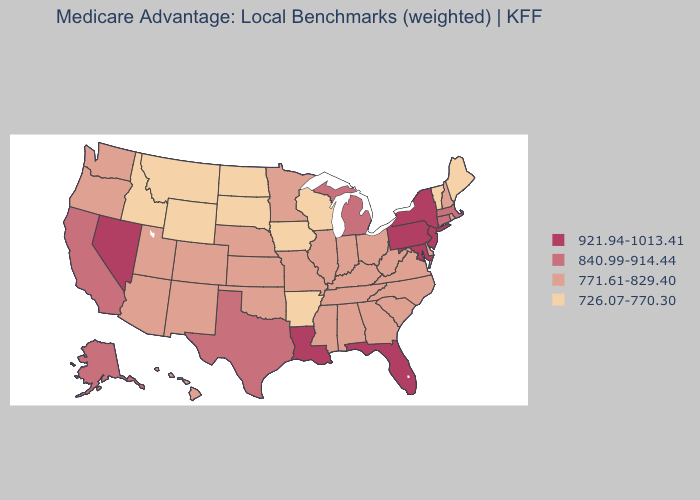Does the map have missing data?
Answer briefly. No. Does Minnesota have the same value as Alaska?
Short answer required. No. Which states hav the highest value in the South?
Write a very short answer. Florida, Louisiana, Maryland. Does Wisconsin have the lowest value in the MidWest?
Keep it brief. Yes. Which states have the lowest value in the USA?
Write a very short answer. Arkansas, Iowa, Idaho, Maine, Montana, North Dakota, South Dakota, Vermont, Wisconsin, Wyoming. Does the map have missing data?
Keep it brief. No. Does the map have missing data?
Quick response, please. No. Name the states that have a value in the range 840.99-914.44?
Concise answer only. Alaska, California, Connecticut, Massachusetts, Michigan, Texas. Which states hav the highest value in the Northeast?
Answer briefly. New Jersey, New York, Pennsylvania. Name the states that have a value in the range 771.61-829.40?
Be succinct. Alabama, Arizona, Colorado, Delaware, Georgia, Hawaii, Illinois, Indiana, Kansas, Kentucky, Minnesota, Missouri, Mississippi, North Carolina, Nebraska, New Hampshire, New Mexico, Ohio, Oklahoma, Oregon, Rhode Island, South Carolina, Tennessee, Utah, Virginia, Washington, West Virginia. Name the states that have a value in the range 921.94-1013.41?
Quick response, please. Florida, Louisiana, Maryland, New Jersey, Nevada, New York, Pennsylvania. Does Massachusetts have the highest value in the USA?
Concise answer only. No. What is the value of Massachusetts?
Give a very brief answer. 840.99-914.44. Does Rhode Island have the same value as Oklahoma?
Be succinct. Yes. What is the value of Rhode Island?
Be succinct. 771.61-829.40. 